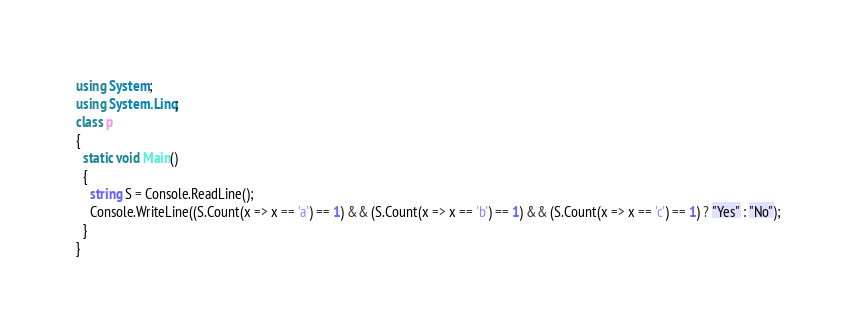<code> <loc_0><loc_0><loc_500><loc_500><_C#_>using System;
using System.Linq;
class p
{
  static void Main()
  {
    string S = Console.ReadLine();
    Console.WriteLine((S.Count(x => x == 'a') == 1) && (S.Count(x => x == 'b') == 1) && (S.Count(x => x == 'c') == 1) ? "Yes" : "No");
  }
}</code> 